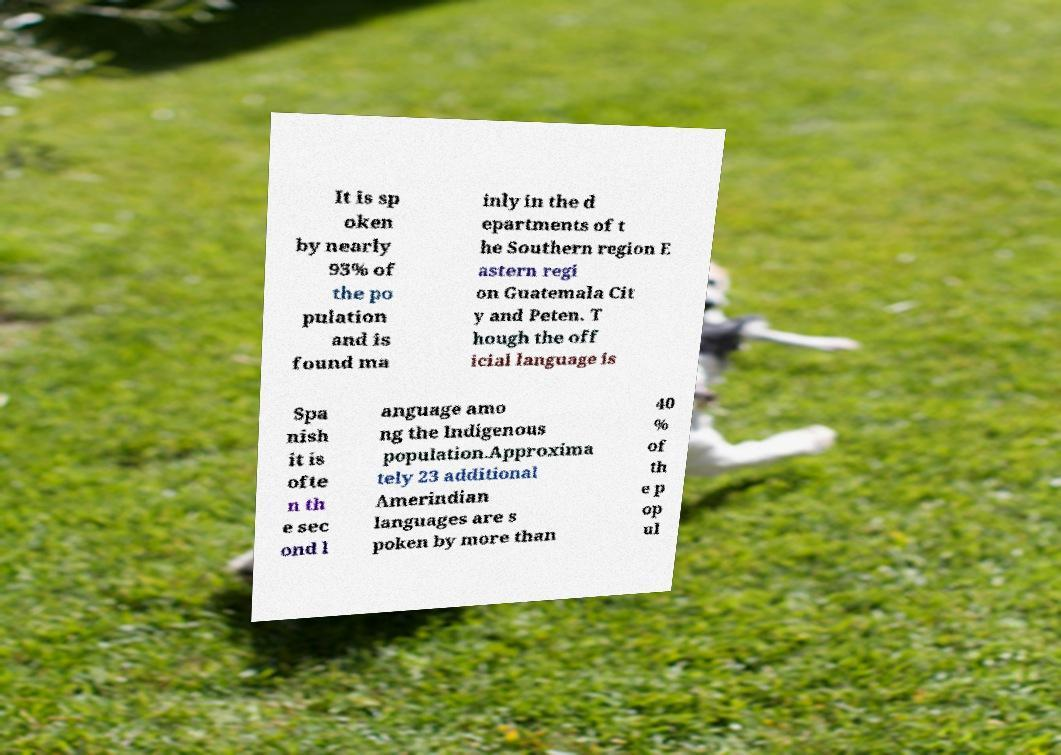Could you assist in decoding the text presented in this image and type it out clearly? It is sp oken by nearly 93% of the po pulation and is found ma inly in the d epartments of t he Southern region E astern regi on Guatemala Cit y and Peten. T hough the off icial language is Spa nish it is ofte n th e sec ond l anguage amo ng the Indigenous population.Approxima tely 23 additional Amerindian languages are s poken by more than 40 % of th e p op ul 